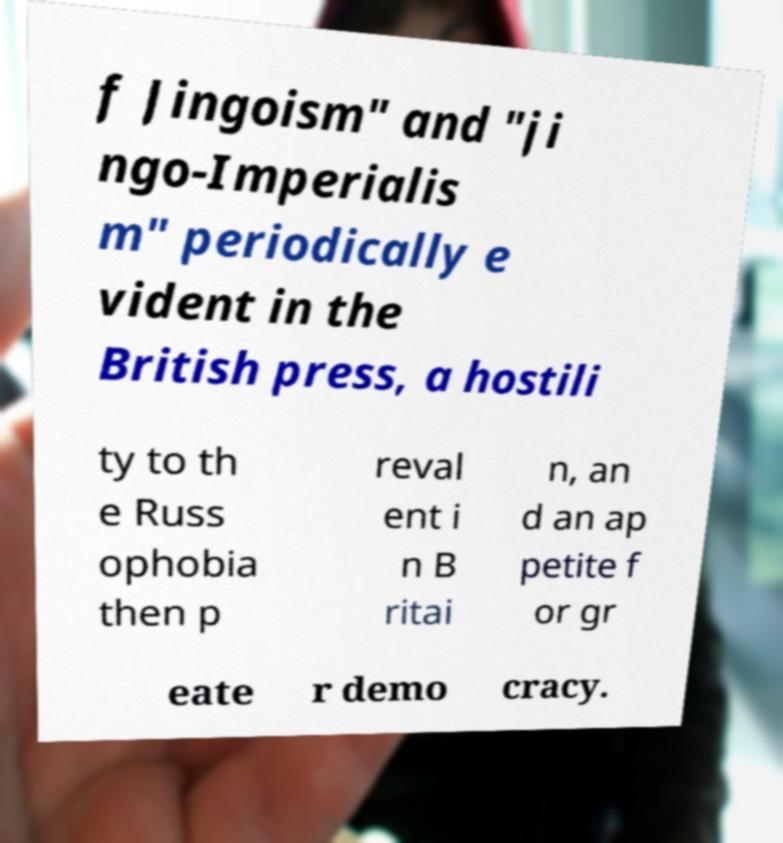Can you read and provide the text displayed in the image?This photo seems to have some interesting text. Can you extract and type it out for me? f Jingoism" and "ji ngo-Imperialis m" periodically e vident in the British press, a hostili ty to th e Russ ophobia then p reval ent i n B ritai n, an d an ap petite f or gr eate r demo cracy. 